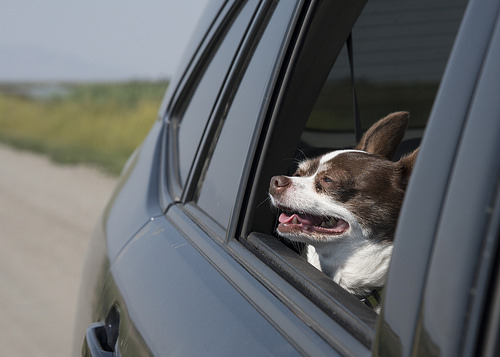<image>
Can you confirm if the dog is on the car? No. The dog is not positioned on the car. They may be near each other, but the dog is not supported by or resting on top of the car. Is there a dog in the car? Yes. The dog is contained within or inside the car, showing a containment relationship. 